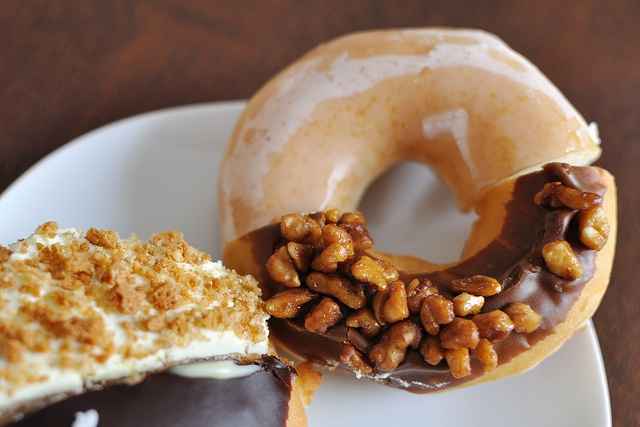Describe the objects in this image and their specific colors. I can see dining table in maroon, darkgray, brown, and lightgray tones, donut in maroon, brown, black, and tan tones, donut in maroon, tan, ivory, red, and black tones, and donut in maroon, tan, and darkgray tones in this image. 